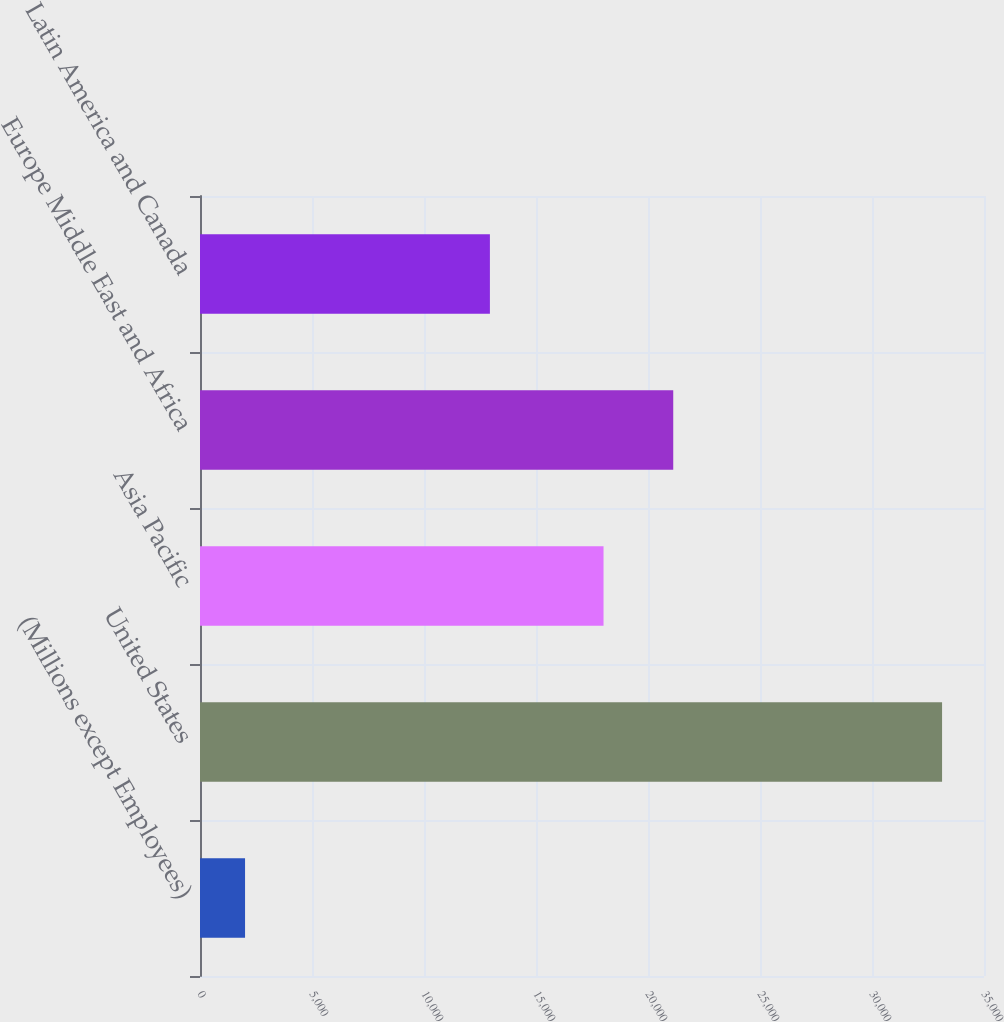Convert chart to OTSL. <chart><loc_0><loc_0><loc_500><loc_500><bar_chart><fcel>(Millions except Employees)<fcel>United States<fcel>Asia Pacific<fcel>Europe Middle East and Africa<fcel>Latin America and Canada<nl><fcel>2011<fcel>33128<fcel>18015<fcel>21126.7<fcel>12942<nl></chart> 